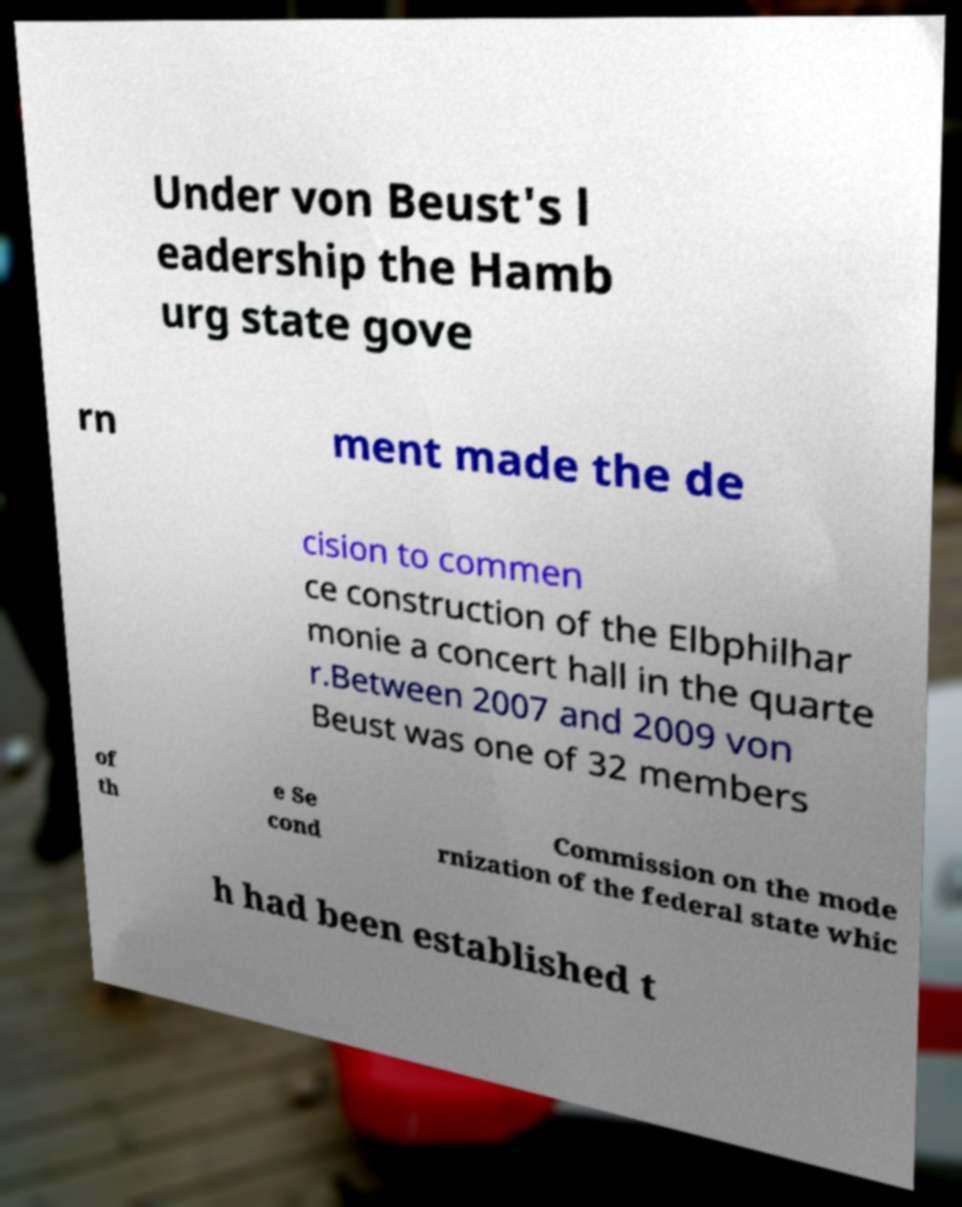Can you accurately transcribe the text from the provided image for me? Under von Beust's l eadership the Hamb urg state gove rn ment made the de cision to commen ce construction of the Elbphilhar monie a concert hall in the quarte r.Between 2007 and 2009 von Beust was one of 32 members of th e Se cond Commission on the mode rnization of the federal state whic h had been established t 